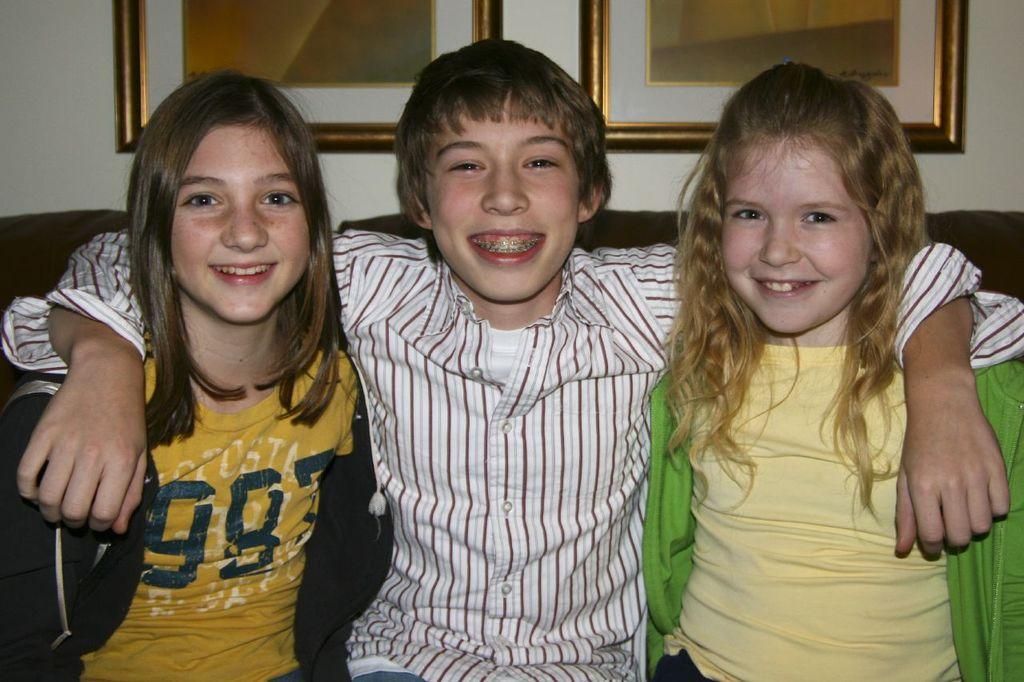How many people are in the image? There are three people in the image. What are the people doing in the image? The people are sitting and smiling. What can be seen in the background of the image? There is a wall in the background of the image. What is placed on the wall in the background? There are frames placed on the wall in the background. What type of locket is the dad holding in the image? There is no dad or locket present in the image. What channel is the TV tuned to in the image? There is no TV present in the image. 